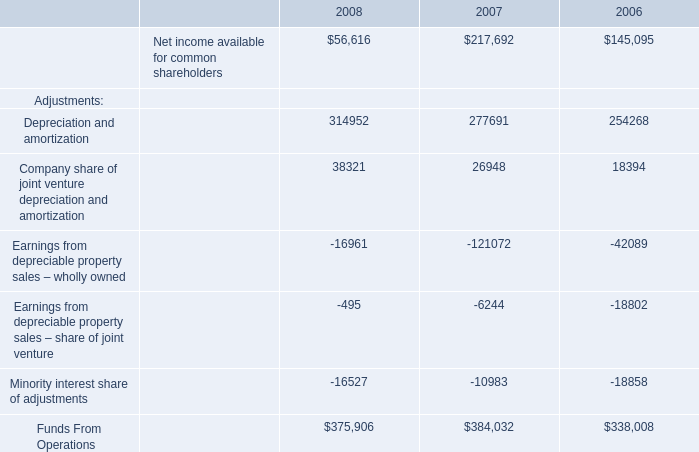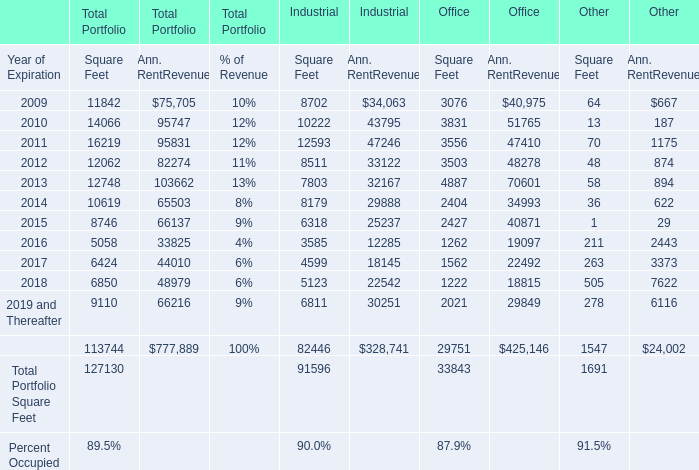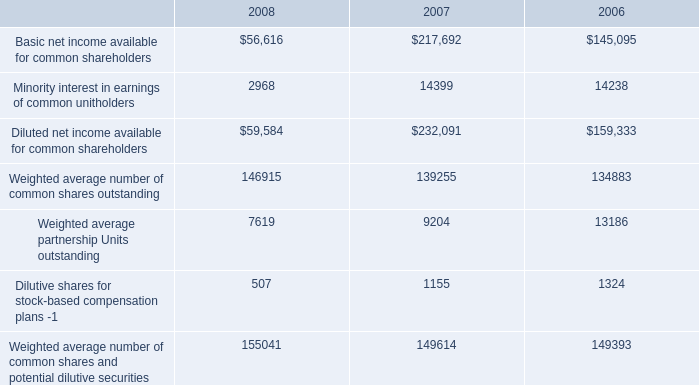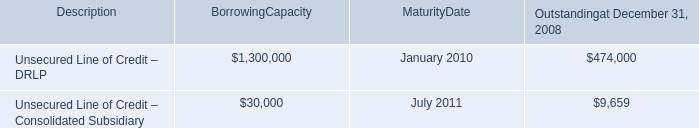what is the net income per common share in 2007? 
Computations: (217692 / 139255)
Answer: 1.56326. 